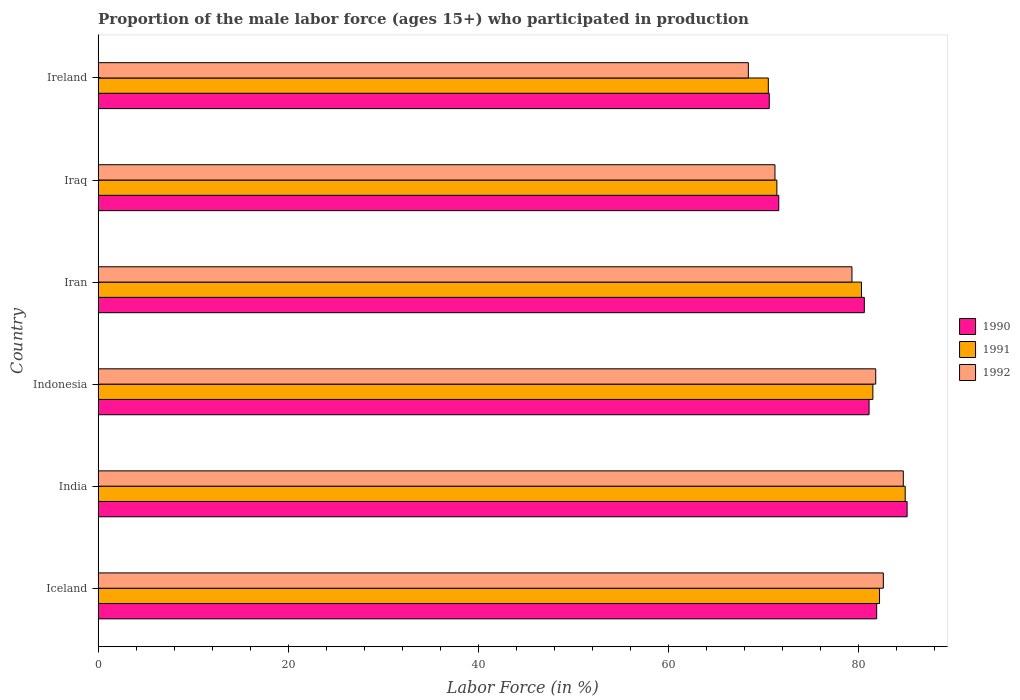How many groups of bars are there?
Provide a short and direct response. 6. How many bars are there on the 3rd tick from the bottom?
Your response must be concise. 3. In how many cases, is the number of bars for a given country not equal to the number of legend labels?
Give a very brief answer. 0. What is the proportion of the male labor force who participated in production in 1990 in India?
Keep it short and to the point. 85.1. Across all countries, what is the maximum proportion of the male labor force who participated in production in 1991?
Provide a short and direct response. 84.9. Across all countries, what is the minimum proportion of the male labor force who participated in production in 1992?
Your answer should be compact. 68.4. In which country was the proportion of the male labor force who participated in production in 1992 minimum?
Provide a short and direct response. Ireland. What is the total proportion of the male labor force who participated in production in 1992 in the graph?
Keep it short and to the point. 468. What is the difference between the proportion of the male labor force who participated in production in 1991 in India and that in Indonesia?
Your answer should be very brief. 3.4. What is the difference between the proportion of the male labor force who participated in production in 1991 in India and the proportion of the male labor force who participated in production in 1992 in Iraq?
Provide a succinct answer. 13.7. What is the average proportion of the male labor force who participated in production in 1992 per country?
Give a very brief answer. 78. What is the difference between the proportion of the male labor force who participated in production in 1991 and proportion of the male labor force who participated in production in 1990 in Iraq?
Provide a short and direct response. -0.2. In how many countries, is the proportion of the male labor force who participated in production in 1991 greater than 60 %?
Make the answer very short. 6. What is the ratio of the proportion of the male labor force who participated in production in 1990 in Iraq to that in Ireland?
Make the answer very short. 1.01. Is the proportion of the male labor force who participated in production in 1992 in India less than that in Iran?
Give a very brief answer. No. What is the difference between the highest and the second highest proportion of the male labor force who participated in production in 1990?
Provide a succinct answer. 3.2. What is the difference between the highest and the lowest proportion of the male labor force who participated in production in 1992?
Your response must be concise. 16.3. What does the 3rd bar from the top in India represents?
Offer a terse response. 1990. What does the 1st bar from the bottom in Iran represents?
Keep it short and to the point. 1990. Is it the case that in every country, the sum of the proportion of the male labor force who participated in production in 1991 and proportion of the male labor force who participated in production in 1990 is greater than the proportion of the male labor force who participated in production in 1992?
Your answer should be very brief. Yes. How many bars are there?
Provide a succinct answer. 18. How many countries are there in the graph?
Keep it short and to the point. 6. What is the difference between two consecutive major ticks on the X-axis?
Provide a short and direct response. 20. Does the graph contain any zero values?
Give a very brief answer. No. How many legend labels are there?
Give a very brief answer. 3. What is the title of the graph?
Provide a short and direct response. Proportion of the male labor force (ages 15+) who participated in production. What is the Labor Force (in %) of 1990 in Iceland?
Your answer should be very brief. 81.9. What is the Labor Force (in %) in 1991 in Iceland?
Provide a short and direct response. 82.2. What is the Labor Force (in %) of 1992 in Iceland?
Ensure brevity in your answer.  82.6. What is the Labor Force (in %) of 1990 in India?
Offer a terse response. 85.1. What is the Labor Force (in %) of 1991 in India?
Make the answer very short. 84.9. What is the Labor Force (in %) of 1992 in India?
Ensure brevity in your answer.  84.7. What is the Labor Force (in %) in 1990 in Indonesia?
Offer a terse response. 81.1. What is the Labor Force (in %) in 1991 in Indonesia?
Provide a short and direct response. 81.5. What is the Labor Force (in %) in 1992 in Indonesia?
Make the answer very short. 81.8. What is the Labor Force (in %) in 1990 in Iran?
Give a very brief answer. 80.6. What is the Labor Force (in %) in 1991 in Iran?
Your response must be concise. 80.3. What is the Labor Force (in %) in 1992 in Iran?
Offer a terse response. 79.3. What is the Labor Force (in %) of 1990 in Iraq?
Give a very brief answer. 71.6. What is the Labor Force (in %) of 1991 in Iraq?
Your response must be concise. 71.4. What is the Labor Force (in %) in 1992 in Iraq?
Provide a succinct answer. 71.2. What is the Labor Force (in %) in 1990 in Ireland?
Your response must be concise. 70.6. What is the Labor Force (in %) of 1991 in Ireland?
Keep it short and to the point. 70.5. What is the Labor Force (in %) in 1992 in Ireland?
Offer a terse response. 68.4. Across all countries, what is the maximum Labor Force (in %) of 1990?
Provide a succinct answer. 85.1. Across all countries, what is the maximum Labor Force (in %) of 1991?
Give a very brief answer. 84.9. Across all countries, what is the maximum Labor Force (in %) in 1992?
Give a very brief answer. 84.7. Across all countries, what is the minimum Labor Force (in %) of 1990?
Offer a terse response. 70.6. Across all countries, what is the minimum Labor Force (in %) of 1991?
Your response must be concise. 70.5. Across all countries, what is the minimum Labor Force (in %) in 1992?
Provide a succinct answer. 68.4. What is the total Labor Force (in %) in 1990 in the graph?
Offer a very short reply. 470.9. What is the total Labor Force (in %) in 1991 in the graph?
Provide a short and direct response. 470.8. What is the total Labor Force (in %) in 1992 in the graph?
Ensure brevity in your answer.  468. What is the difference between the Labor Force (in %) in 1991 in Iceland and that in India?
Offer a very short reply. -2.7. What is the difference between the Labor Force (in %) in 1992 in Iceland and that in India?
Offer a very short reply. -2.1. What is the difference between the Labor Force (in %) in 1990 in Iceland and that in Indonesia?
Your response must be concise. 0.8. What is the difference between the Labor Force (in %) of 1992 in Iceland and that in Indonesia?
Keep it short and to the point. 0.8. What is the difference between the Labor Force (in %) of 1991 in Iceland and that in Iran?
Ensure brevity in your answer.  1.9. What is the difference between the Labor Force (in %) of 1992 in Iceland and that in Iran?
Offer a very short reply. 3.3. What is the difference between the Labor Force (in %) in 1990 in Iceland and that in Iraq?
Provide a succinct answer. 10.3. What is the difference between the Labor Force (in %) in 1990 in Iceland and that in Ireland?
Offer a very short reply. 11.3. What is the difference between the Labor Force (in %) of 1992 in India and that in Indonesia?
Keep it short and to the point. 2.9. What is the difference between the Labor Force (in %) of 1990 in India and that in Iran?
Offer a terse response. 4.5. What is the difference between the Labor Force (in %) of 1991 in India and that in Iraq?
Offer a terse response. 13.5. What is the difference between the Labor Force (in %) of 1992 in India and that in Iraq?
Offer a terse response. 13.5. What is the difference between the Labor Force (in %) of 1990 in India and that in Ireland?
Your answer should be compact. 14.5. What is the difference between the Labor Force (in %) of 1990 in Indonesia and that in Iran?
Your answer should be compact. 0.5. What is the difference between the Labor Force (in %) in 1991 in Indonesia and that in Iran?
Give a very brief answer. 1.2. What is the difference between the Labor Force (in %) in 1992 in Indonesia and that in Iran?
Offer a terse response. 2.5. What is the difference between the Labor Force (in %) of 1991 in Indonesia and that in Iraq?
Your answer should be very brief. 10.1. What is the difference between the Labor Force (in %) of 1990 in Indonesia and that in Ireland?
Your answer should be very brief. 10.5. What is the difference between the Labor Force (in %) in 1991 in Indonesia and that in Ireland?
Make the answer very short. 11. What is the difference between the Labor Force (in %) of 1992 in Iran and that in Iraq?
Your answer should be very brief. 8.1. What is the difference between the Labor Force (in %) of 1990 in Iran and that in Ireland?
Your answer should be very brief. 10. What is the difference between the Labor Force (in %) of 1991 in Iran and that in Ireland?
Your response must be concise. 9.8. What is the difference between the Labor Force (in %) of 1992 in Iran and that in Ireland?
Make the answer very short. 10.9. What is the difference between the Labor Force (in %) of 1991 in Iraq and that in Ireland?
Make the answer very short. 0.9. What is the difference between the Labor Force (in %) in 1992 in Iraq and that in Ireland?
Offer a terse response. 2.8. What is the difference between the Labor Force (in %) in 1990 in Iceland and the Labor Force (in %) in 1991 in Indonesia?
Provide a succinct answer. 0.4. What is the difference between the Labor Force (in %) in 1990 in Iceland and the Labor Force (in %) in 1992 in Indonesia?
Your answer should be compact. 0.1. What is the difference between the Labor Force (in %) in 1991 in Iceland and the Labor Force (in %) in 1992 in Indonesia?
Offer a terse response. 0.4. What is the difference between the Labor Force (in %) of 1991 in Iceland and the Labor Force (in %) of 1992 in Iran?
Your answer should be compact. 2.9. What is the difference between the Labor Force (in %) of 1990 in Iceland and the Labor Force (in %) of 1992 in Iraq?
Provide a succinct answer. 10.7. What is the difference between the Labor Force (in %) in 1990 in Iceland and the Labor Force (in %) in 1991 in Ireland?
Offer a very short reply. 11.4. What is the difference between the Labor Force (in %) of 1990 in India and the Labor Force (in %) of 1991 in Indonesia?
Your answer should be compact. 3.6. What is the difference between the Labor Force (in %) in 1990 in India and the Labor Force (in %) in 1992 in Indonesia?
Make the answer very short. 3.3. What is the difference between the Labor Force (in %) of 1990 in India and the Labor Force (in %) of 1991 in Iran?
Provide a short and direct response. 4.8. What is the difference between the Labor Force (in %) of 1991 in India and the Labor Force (in %) of 1992 in Iran?
Provide a succinct answer. 5.6. What is the difference between the Labor Force (in %) of 1990 in India and the Labor Force (in %) of 1992 in Iraq?
Your answer should be very brief. 13.9. What is the difference between the Labor Force (in %) in 1991 in India and the Labor Force (in %) in 1992 in Iraq?
Keep it short and to the point. 13.7. What is the difference between the Labor Force (in %) of 1990 in India and the Labor Force (in %) of 1991 in Ireland?
Your answer should be very brief. 14.6. What is the difference between the Labor Force (in %) of 1990 in India and the Labor Force (in %) of 1992 in Ireland?
Keep it short and to the point. 16.7. What is the difference between the Labor Force (in %) of 1991 in India and the Labor Force (in %) of 1992 in Ireland?
Your response must be concise. 16.5. What is the difference between the Labor Force (in %) in 1990 in Indonesia and the Labor Force (in %) in 1991 in Iran?
Offer a very short reply. 0.8. What is the difference between the Labor Force (in %) in 1990 in Indonesia and the Labor Force (in %) in 1992 in Iran?
Make the answer very short. 1.8. What is the difference between the Labor Force (in %) in 1991 in Indonesia and the Labor Force (in %) in 1992 in Iran?
Ensure brevity in your answer.  2.2. What is the difference between the Labor Force (in %) of 1990 in Indonesia and the Labor Force (in %) of 1991 in Iraq?
Your answer should be compact. 9.7. What is the difference between the Labor Force (in %) in 1990 in Indonesia and the Labor Force (in %) in 1991 in Ireland?
Your response must be concise. 10.6. What is the difference between the Labor Force (in %) of 1990 in Indonesia and the Labor Force (in %) of 1992 in Ireland?
Your response must be concise. 12.7. What is the difference between the Labor Force (in %) of 1990 in Iran and the Labor Force (in %) of 1991 in Iraq?
Ensure brevity in your answer.  9.2. What is the difference between the Labor Force (in %) in 1991 in Iran and the Labor Force (in %) in 1992 in Iraq?
Offer a terse response. 9.1. What is the difference between the Labor Force (in %) in 1991 in Iran and the Labor Force (in %) in 1992 in Ireland?
Offer a very short reply. 11.9. What is the difference between the Labor Force (in %) in 1990 in Iraq and the Labor Force (in %) in 1991 in Ireland?
Make the answer very short. 1.1. What is the difference between the Labor Force (in %) in 1990 in Iraq and the Labor Force (in %) in 1992 in Ireland?
Your answer should be very brief. 3.2. What is the average Labor Force (in %) in 1990 per country?
Keep it short and to the point. 78.48. What is the average Labor Force (in %) in 1991 per country?
Make the answer very short. 78.47. What is the difference between the Labor Force (in %) in 1990 and Labor Force (in %) in 1991 in Iceland?
Provide a succinct answer. -0.3. What is the difference between the Labor Force (in %) of 1990 and Labor Force (in %) of 1992 in Iceland?
Keep it short and to the point. -0.7. What is the difference between the Labor Force (in %) of 1990 and Labor Force (in %) of 1991 in India?
Make the answer very short. 0.2. What is the difference between the Labor Force (in %) in 1990 and Labor Force (in %) in 1992 in Indonesia?
Offer a terse response. -0.7. What is the difference between the Labor Force (in %) in 1991 and Labor Force (in %) in 1992 in Indonesia?
Provide a short and direct response. -0.3. What is the difference between the Labor Force (in %) in 1990 and Labor Force (in %) in 1992 in Iran?
Give a very brief answer. 1.3. What is the difference between the Labor Force (in %) of 1990 and Labor Force (in %) of 1992 in Iraq?
Give a very brief answer. 0.4. What is the difference between the Labor Force (in %) of 1990 and Labor Force (in %) of 1991 in Ireland?
Ensure brevity in your answer.  0.1. What is the difference between the Labor Force (in %) of 1990 and Labor Force (in %) of 1992 in Ireland?
Give a very brief answer. 2.2. What is the ratio of the Labor Force (in %) in 1990 in Iceland to that in India?
Offer a very short reply. 0.96. What is the ratio of the Labor Force (in %) in 1991 in Iceland to that in India?
Ensure brevity in your answer.  0.97. What is the ratio of the Labor Force (in %) in 1992 in Iceland to that in India?
Ensure brevity in your answer.  0.98. What is the ratio of the Labor Force (in %) in 1990 in Iceland to that in Indonesia?
Provide a short and direct response. 1.01. What is the ratio of the Labor Force (in %) in 1991 in Iceland to that in Indonesia?
Ensure brevity in your answer.  1.01. What is the ratio of the Labor Force (in %) in 1992 in Iceland to that in Indonesia?
Offer a very short reply. 1.01. What is the ratio of the Labor Force (in %) in 1990 in Iceland to that in Iran?
Your response must be concise. 1.02. What is the ratio of the Labor Force (in %) in 1991 in Iceland to that in Iran?
Provide a succinct answer. 1.02. What is the ratio of the Labor Force (in %) of 1992 in Iceland to that in Iran?
Provide a short and direct response. 1.04. What is the ratio of the Labor Force (in %) in 1990 in Iceland to that in Iraq?
Keep it short and to the point. 1.14. What is the ratio of the Labor Force (in %) in 1991 in Iceland to that in Iraq?
Provide a succinct answer. 1.15. What is the ratio of the Labor Force (in %) in 1992 in Iceland to that in Iraq?
Your answer should be compact. 1.16. What is the ratio of the Labor Force (in %) of 1990 in Iceland to that in Ireland?
Your response must be concise. 1.16. What is the ratio of the Labor Force (in %) of 1991 in Iceland to that in Ireland?
Your response must be concise. 1.17. What is the ratio of the Labor Force (in %) of 1992 in Iceland to that in Ireland?
Your response must be concise. 1.21. What is the ratio of the Labor Force (in %) in 1990 in India to that in Indonesia?
Provide a succinct answer. 1.05. What is the ratio of the Labor Force (in %) in 1991 in India to that in Indonesia?
Offer a very short reply. 1.04. What is the ratio of the Labor Force (in %) in 1992 in India to that in Indonesia?
Offer a terse response. 1.04. What is the ratio of the Labor Force (in %) of 1990 in India to that in Iran?
Provide a short and direct response. 1.06. What is the ratio of the Labor Force (in %) in 1991 in India to that in Iran?
Offer a very short reply. 1.06. What is the ratio of the Labor Force (in %) in 1992 in India to that in Iran?
Ensure brevity in your answer.  1.07. What is the ratio of the Labor Force (in %) of 1990 in India to that in Iraq?
Offer a very short reply. 1.19. What is the ratio of the Labor Force (in %) of 1991 in India to that in Iraq?
Your response must be concise. 1.19. What is the ratio of the Labor Force (in %) in 1992 in India to that in Iraq?
Give a very brief answer. 1.19. What is the ratio of the Labor Force (in %) of 1990 in India to that in Ireland?
Your answer should be compact. 1.21. What is the ratio of the Labor Force (in %) in 1991 in India to that in Ireland?
Provide a short and direct response. 1.2. What is the ratio of the Labor Force (in %) in 1992 in India to that in Ireland?
Make the answer very short. 1.24. What is the ratio of the Labor Force (in %) in 1990 in Indonesia to that in Iran?
Provide a short and direct response. 1.01. What is the ratio of the Labor Force (in %) of 1991 in Indonesia to that in Iran?
Provide a succinct answer. 1.01. What is the ratio of the Labor Force (in %) of 1992 in Indonesia to that in Iran?
Your answer should be compact. 1.03. What is the ratio of the Labor Force (in %) of 1990 in Indonesia to that in Iraq?
Keep it short and to the point. 1.13. What is the ratio of the Labor Force (in %) in 1991 in Indonesia to that in Iraq?
Provide a succinct answer. 1.14. What is the ratio of the Labor Force (in %) of 1992 in Indonesia to that in Iraq?
Make the answer very short. 1.15. What is the ratio of the Labor Force (in %) in 1990 in Indonesia to that in Ireland?
Provide a succinct answer. 1.15. What is the ratio of the Labor Force (in %) of 1991 in Indonesia to that in Ireland?
Offer a terse response. 1.16. What is the ratio of the Labor Force (in %) of 1992 in Indonesia to that in Ireland?
Offer a very short reply. 1.2. What is the ratio of the Labor Force (in %) of 1990 in Iran to that in Iraq?
Offer a very short reply. 1.13. What is the ratio of the Labor Force (in %) of 1991 in Iran to that in Iraq?
Keep it short and to the point. 1.12. What is the ratio of the Labor Force (in %) in 1992 in Iran to that in Iraq?
Give a very brief answer. 1.11. What is the ratio of the Labor Force (in %) of 1990 in Iran to that in Ireland?
Your answer should be very brief. 1.14. What is the ratio of the Labor Force (in %) in 1991 in Iran to that in Ireland?
Your answer should be compact. 1.14. What is the ratio of the Labor Force (in %) of 1992 in Iran to that in Ireland?
Give a very brief answer. 1.16. What is the ratio of the Labor Force (in %) of 1990 in Iraq to that in Ireland?
Ensure brevity in your answer.  1.01. What is the ratio of the Labor Force (in %) of 1991 in Iraq to that in Ireland?
Provide a succinct answer. 1.01. What is the ratio of the Labor Force (in %) in 1992 in Iraq to that in Ireland?
Your response must be concise. 1.04. What is the difference between the highest and the second highest Labor Force (in %) of 1991?
Make the answer very short. 2.7. What is the difference between the highest and the lowest Labor Force (in %) of 1991?
Make the answer very short. 14.4. 